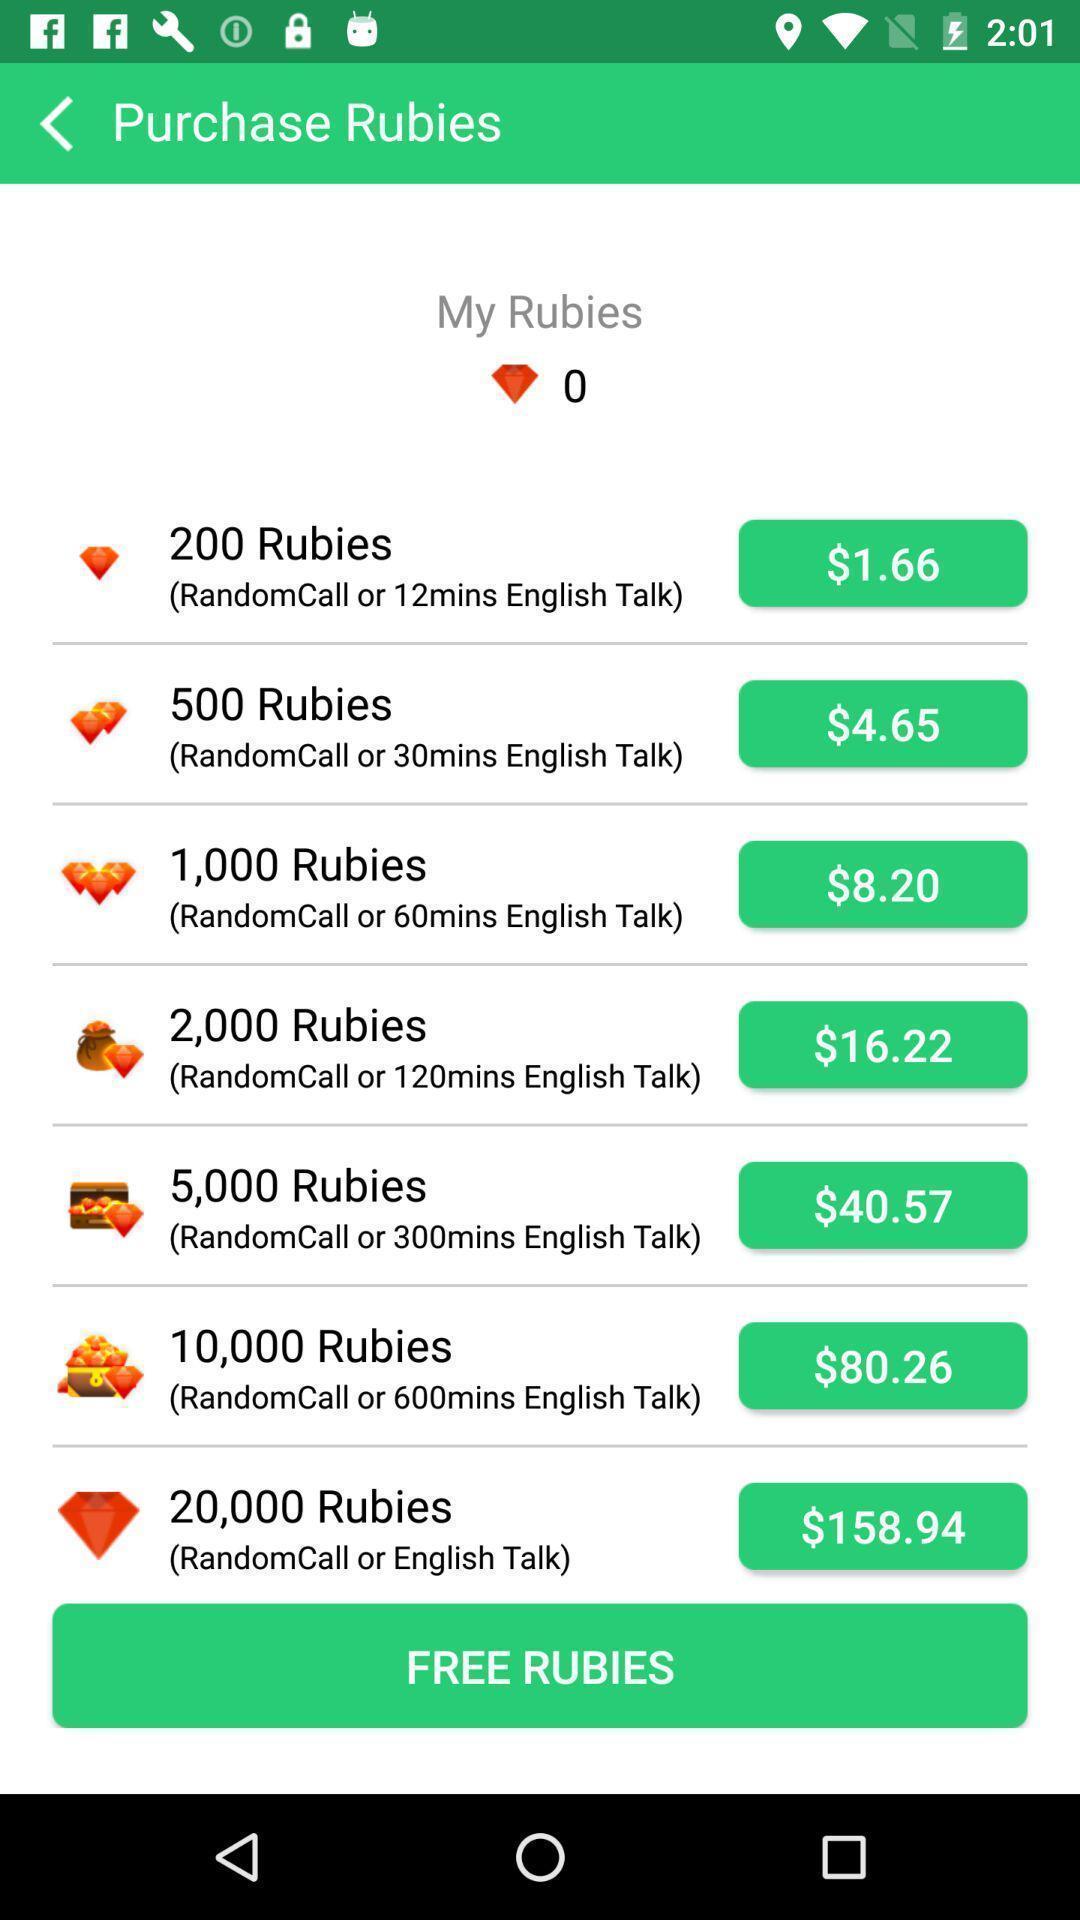Give me a narrative description of this picture. Screen displaying purchase rubies page. 